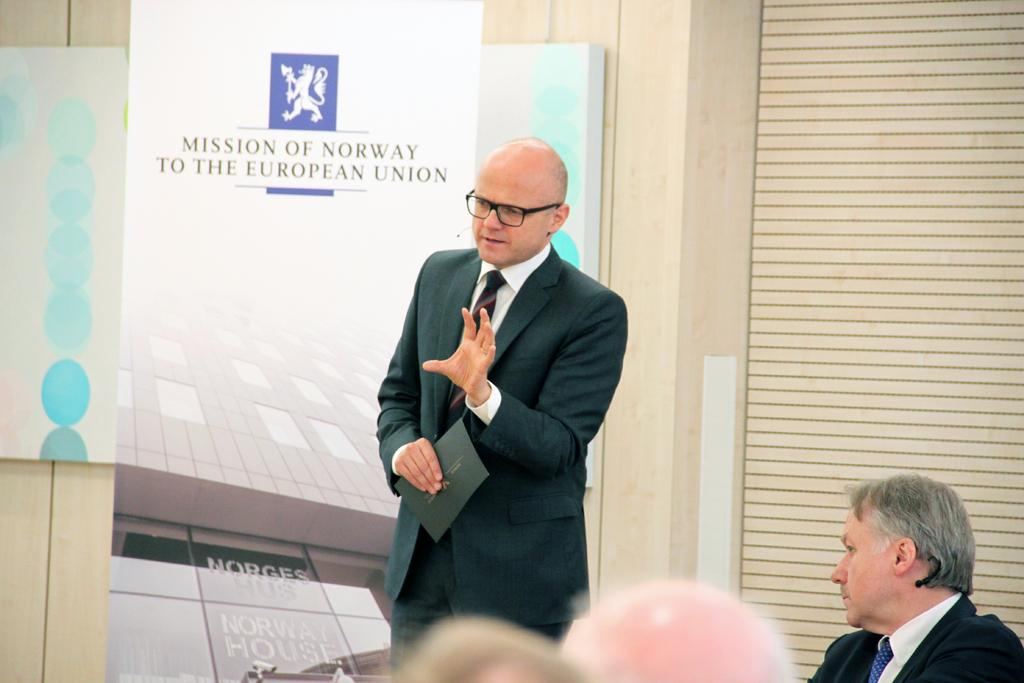Who is the main subject in the image? There is a man in the center of the image. Where are the other people located in the image? There are people at the bottom side of the image. What can be seen in the background of the image? There is a poster in the background of the image. How many ants can be seen crawling on the man in the image? There are no ants present in the image; the man is not interacting with any ants. 